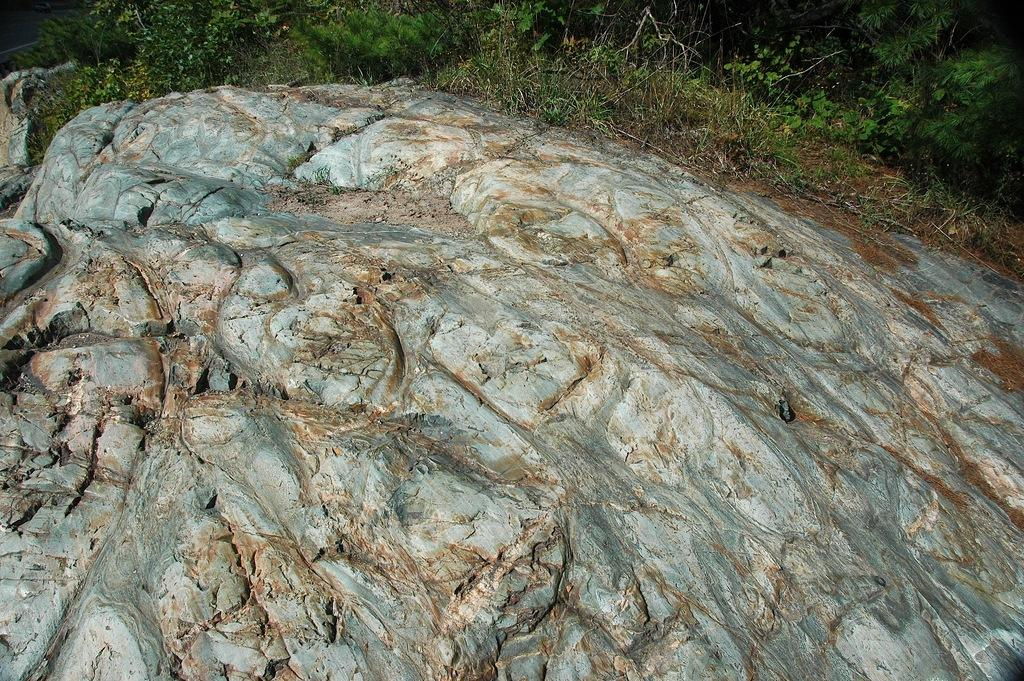What is the main subject of the image? The main subject of the image is a rock. What else can be seen in the image besides the rock? There are small plants in the image. What is the color of the plants? The plants are green in color. How many apples are hanging from the rock in the image? There are no apples present in the image; it features a rock and small green plants. 